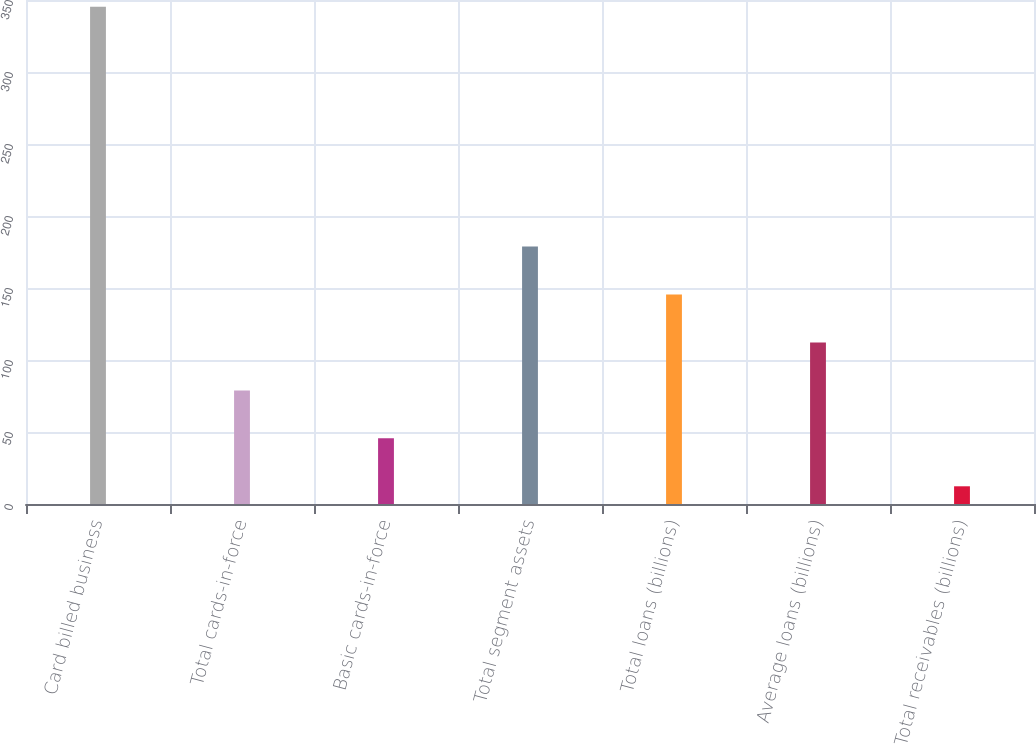<chart> <loc_0><loc_0><loc_500><loc_500><bar_chart><fcel>Card billed business<fcel>Total cards-in-force<fcel>Basic cards-in-force<fcel>Total segment assets<fcel>Total loans (billions)<fcel>Average loans (billions)<fcel>Total receivables (billions)<nl><fcel>345.3<fcel>78.9<fcel>45.6<fcel>178.8<fcel>145.5<fcel>112.2<fcel>12.3<nl></chart> 